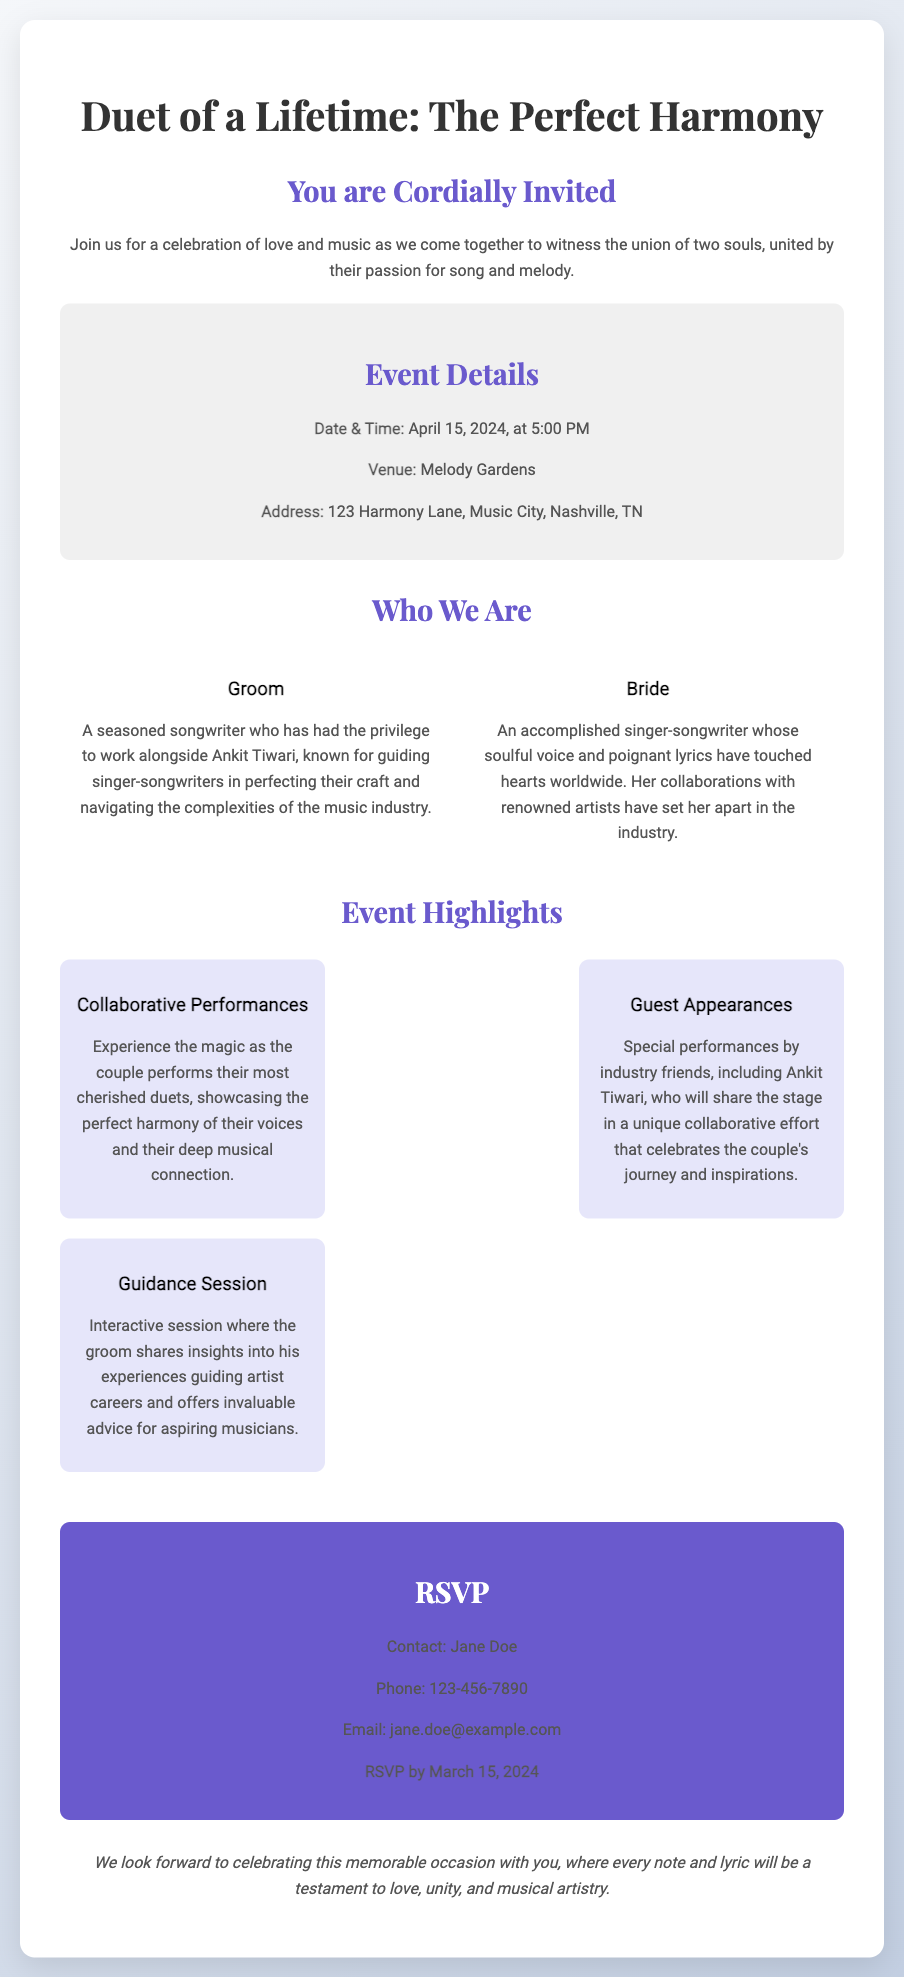What is the date of the wedding? The document specifies the wedding date as April 15, 2024.
Answer: April 15, 2024 Where will the event take place? According to the document, the venue for the wedding is Melody Gardens.
Answer: Melody Gardens Who is the groom? The document describes the groom as a seasoned songwriter who has worked with Ankit Tiwari.
Answer: A seasoned songwriter What will the couple showcase during the event? The invitation mentions that the couple will perform their most cherished duets.
Answer: Cherished duets What is the RSVP deadline? The document states that the RSVP should be made by March 15, 2024.
Answer: March 15, 2024 What special performances are mentioned in the event highlights? The event highlights special performances by industry friends, including Ankit Tiwari.
Answer: Ankit Tiwari What is the nature of the guidance session mentioned? The document mentions an interactive session where the groom shares insights into guiding artist careers.
Answer: Insights into guiding artist careers What theme does the invitation focus on? The invitation emphasizes the perfect harmony and collaboration between the couple.
Answer: Perfect harmony What should guests include when RSVPing? The document indicates that guests should provide their contact details for the RSVP.
Answer: Contact details 